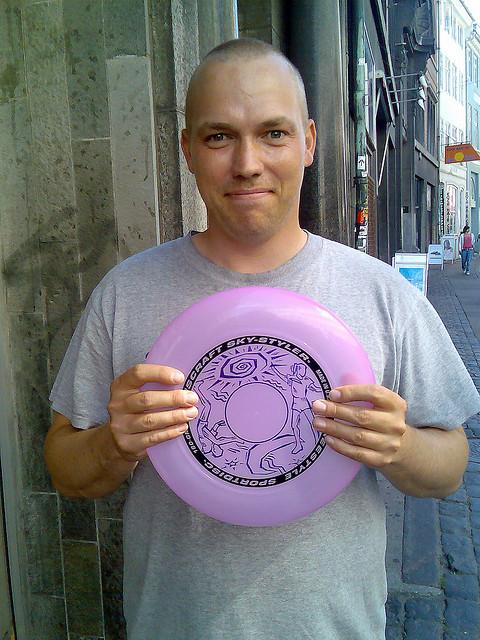This frisbee is how many grams? Please explain your reasoning. 160. Frisbees have a standard weight of 160 grams. 